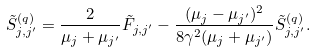<formula> <loc_0><loc_0><loc_500><loc_500>\tilde { S } ^ { ( q ) } _ { j , j ^ { \prime } } = \frac { 2 } { \mu _ { j } + \mu _ { j ^ { \prime } } } \tilde { F } _ { j , j ^ { \prime } } - \frac { ( \mu _ { j } - \mu _ { j ^ { \prime } } ) ^ { 2 } } { 8 \gamma ^ { 2 } ( \mu _ { j } + \mu _ { j ^ { \prime } } ) } \tilde { S } ^ { ( q ) } _ { j , j ^ { \prime } } .</formula> 